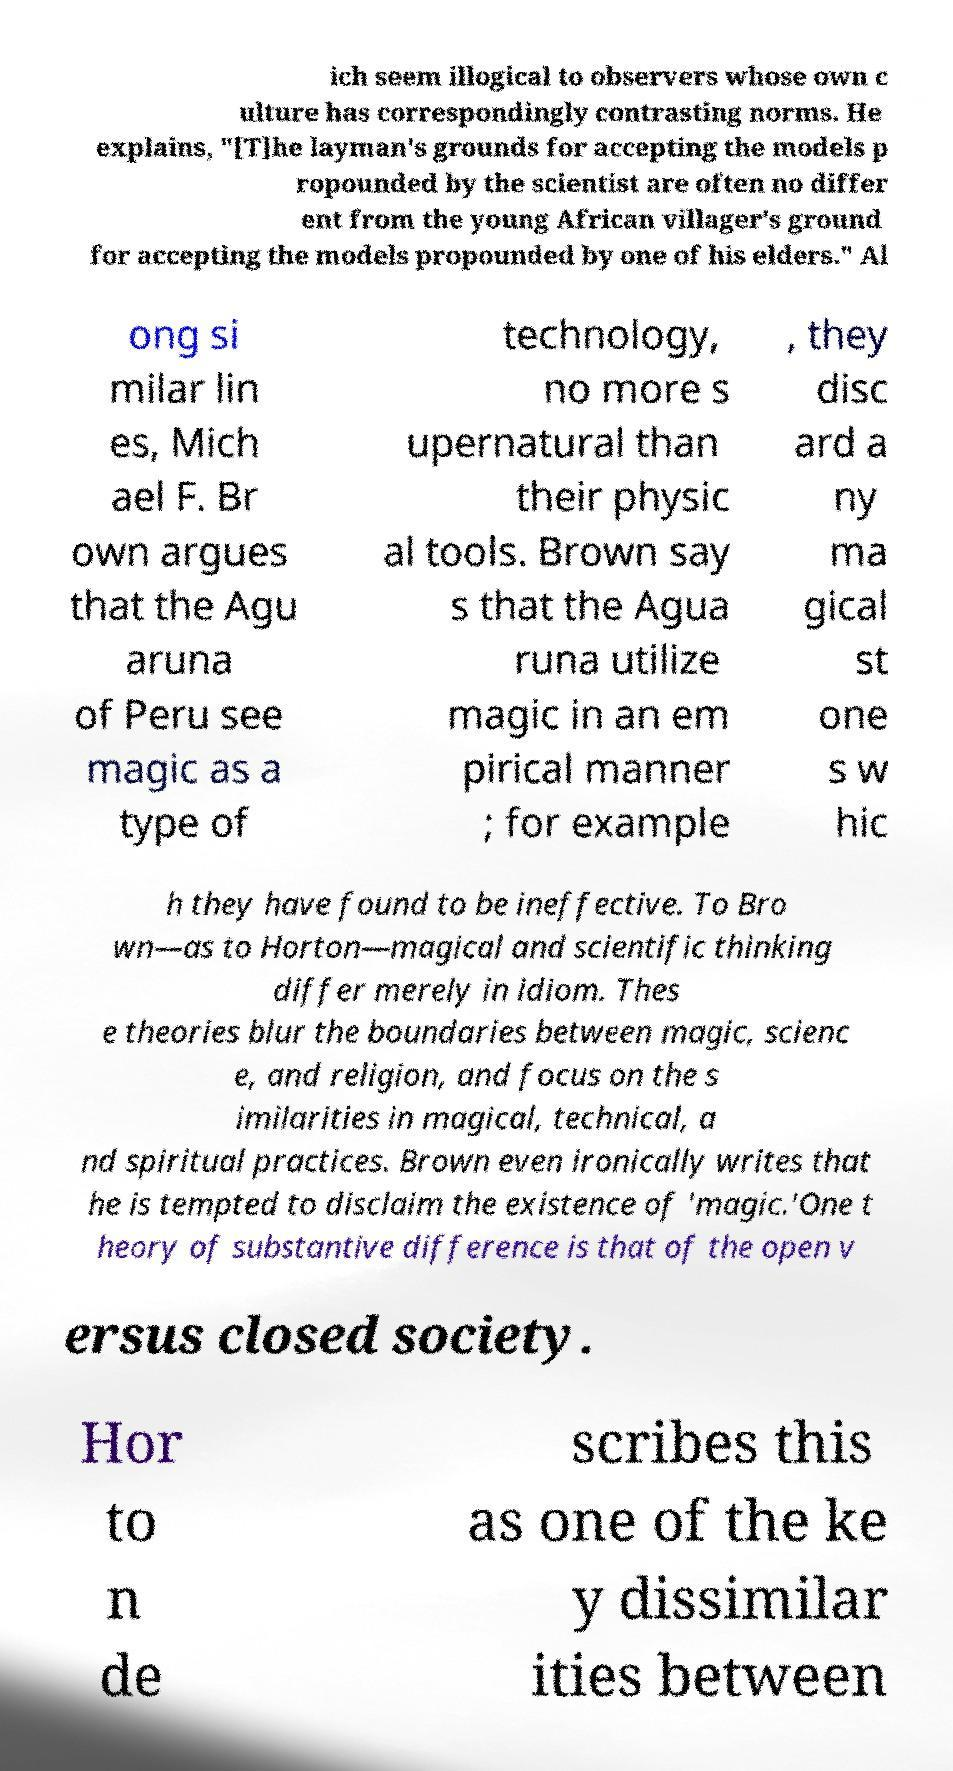Can you read and provide the text displayed in the image?This photo seems to have some interesting text. Can you extract and type it out for me? ich seem illogical to observers whose own c ulture has correspondingly contrasting norms. He explains, "[T]he layman's grounds for accepting the models p ropounded by the scientist are often no differ ent from the young African villager's ground for accepting the models propounded by one of his elders." Al ong si milar lin es, Mich ael F. Br own argues that the Agu aruna of Peru see magic as a type of technology, no more s upernatural than their physic al tools. Brown say s that the Agua runa utilize magic in an em pirical manner ; for example , they disc ard a ny ma gical st one s w hic h they have found to be ineffective. To Bro wn—as to Horton—magical and scientific thinking differ merely in idiom. Thes e theories blur the boundaries between magic, scienc e, and religion, and focus on the s imilarities in magical, technical, a nd spiritual practices. Brown even ironically writes that he is tempted to disclaim the existence of 'magic.'One t heory of substantive difference is that of the open v ersus closed society. Hor to n de scribes this as one of the ke y dissimilar ities between 